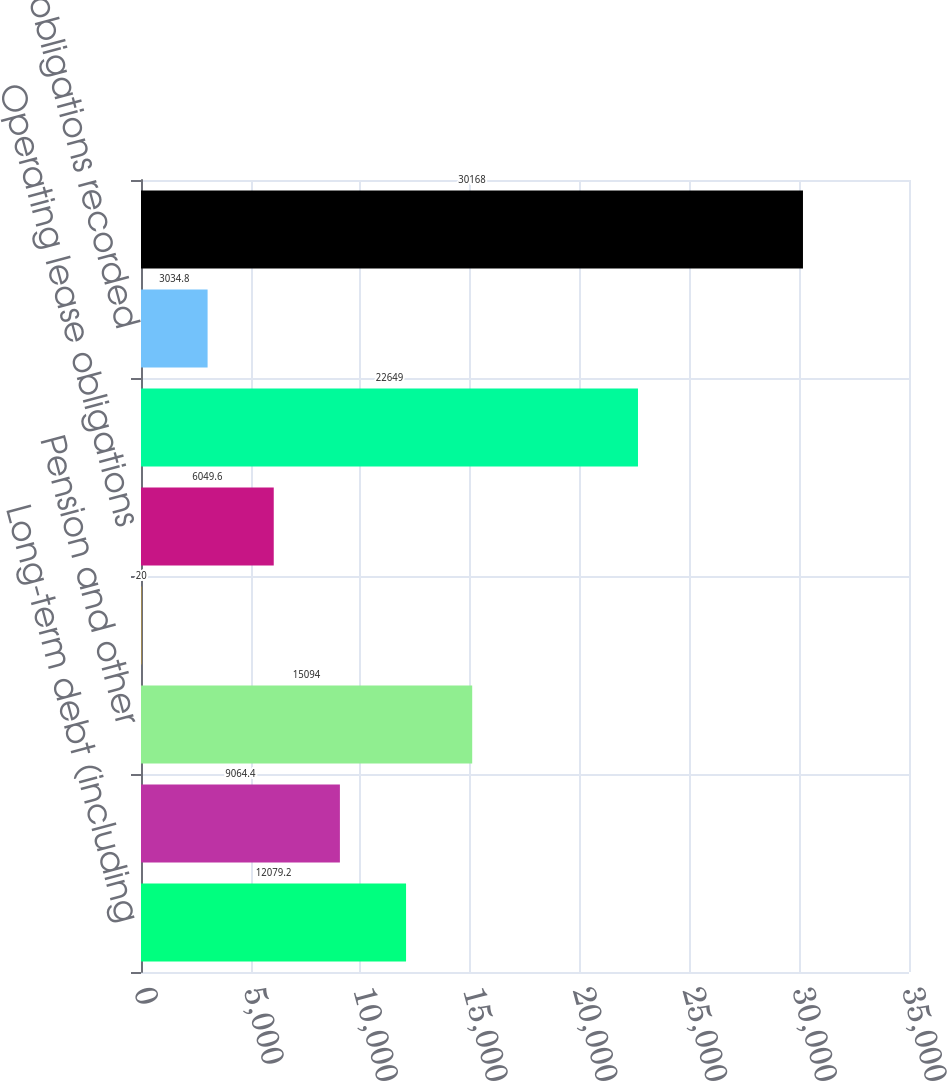Convert chart. <chart><loc_0><loc_0><loc_500><loc_500><bar_chart><fcel>Long-term debt (including<fcel>Interest on debt<fcel>Pension and other<fcel>Capital lease obligations<fcel>Operating lease obligations<fcel>Purchase obligations not<fcel>Purchase obligations recorded<fcel>Total contractual obligations<nl><fcel>12079.2<fcel>9064.4<fcel>15094<fcel>20<fcel>6049.6<fcel>22649<fcel>3034.8<fcel>30168<nl></chart> 